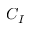<formula> <loc_0><loc_0><loc_500><loc_500>C _ { I }</formula> 